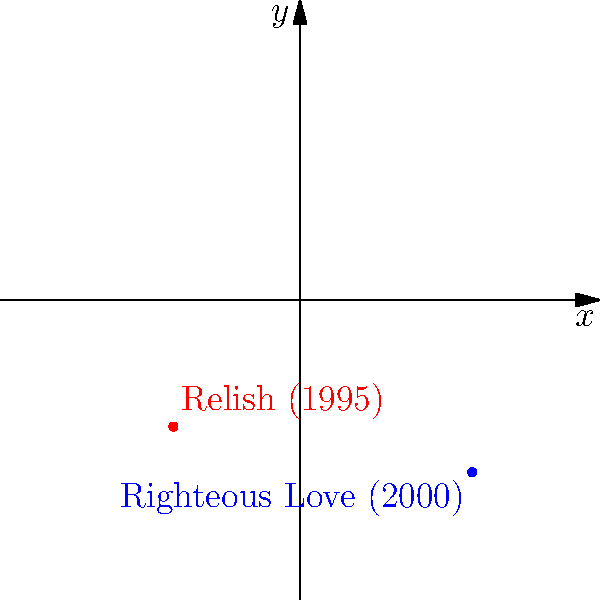Joan Osborne's debut album "Relish" was released in 1995, and her follow-up "Righteous Love" came out in 2000. On the polar coordinate system, "Relish" is represented by the point $(r_1, \theta_1) = (5.98, \frac{5\pi}{4})$, and "Righteous Love" by $(r_2, \theta_2) = (8.14, \frac{7\pi}{4})$. What are the Cartesian coordinates $(x, y)$ of the point representing "Righteous Love"? To convert polar coordinates $(r, \theta)$ to Cartesian coordinates $(x, y)$, we use these formulas:

$$x = r \cos(\theta)$$
$$y = r \sin(\theta)$$

For "Righteous Love", we have:
$r_2 = 8.14$ and $\theta_2 = \frac{7\pi}{4}$

Step 1: Calculate $x$
$$x = r_2 \cos(\theta_2) = 8.14 \cos(\frac{7\pi}{4})$$
$$x = 8.14 \cdot \frac{\sqrt{2}}{2} = 5.75$$

Step 2: Calculate $y$
$$y = r_2 \sin(\theta_2) = 8.14 \sin(\frac{7\pi}{4})$$
$$y = 8.14 \cdot (-\frac{\sqrt{2}}{2}) = -5.75$$

Therefore, the Cartesian coordinates for "Righteous Love" are $(5.75, -5.75)$.
Answer: $(5.75, -5.75)$ 